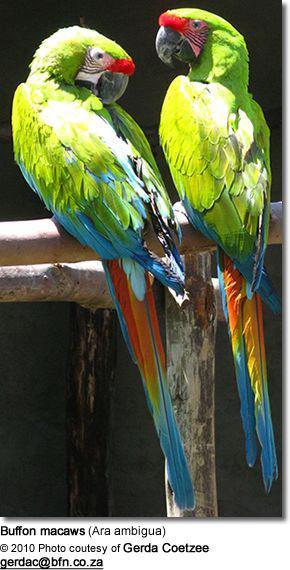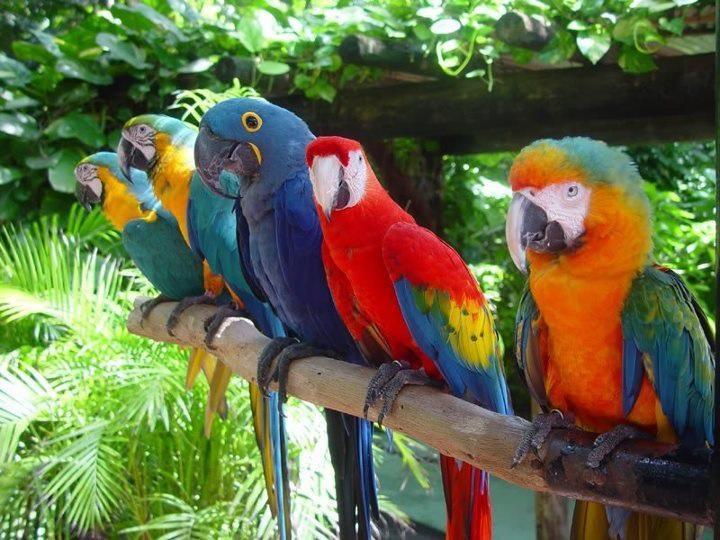The first image is the image on the left, the second image is the image on the right. Given the left and right images, does the statement "There are less than four birds." hold true? Answer yes or no. No. The first image is the image on the left, the second image is the image on the right. Evaluate the accuracy of this statement regarding the images: "More than four parrots are standing on the same stick and facing the same direction.". Is it true? Answer yes or no. Yes. The first image is the image on the left, the second image is the image on the right. Assess this claim about the two images: "There are no more than three birds". Correct or not? Answer yes or no. No. 